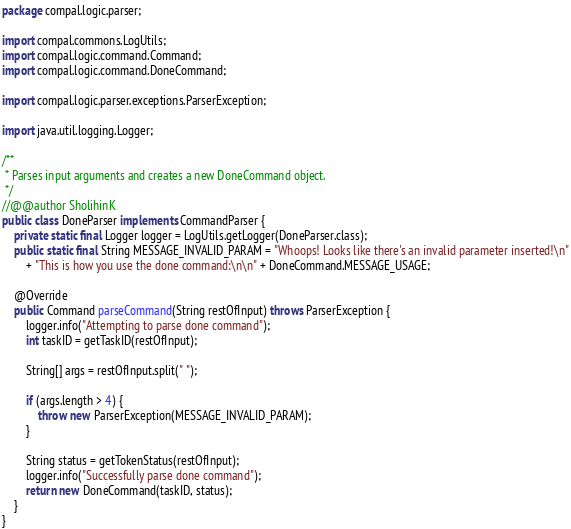<code> <loc_0><loc_0><loc_500><loc_500><_Java_>package compal.logic.parser;

import compal.commons.LogUtils;
import compal.logic.command.Command;
import compal.logic.command.DoneCommand;

import compal.logic.parser.exceptions.ParserException;

import java.util.logging.Logger;

/**
 * Parses input arguments and creates a new DoneCommand object.
 */
//@@author SholihinK
public class DoneParser implements CommandParser {
    private static final Logger logger = LogUtils.getLogger(DoneParser.class);
    public static final String MESSAGE_INVALID_PARAM = "Whoops! Looks like there's an invalid parameter inserted!\n"
        + "This is how you use the done command:\n\n" + DoneCommand.MESSAGE_USAGE;

    @Override
    public Command parseCommand(String restOfInput) throws ParserException {
        logger.info("Attempting to parse done command");
        int taskID = getTaskID(restOfInput);

        String[] args = restOfInput.split(" ");

        if (args.length > 4) {
            throw new ParserException(MESSAGE_INVALID_PARAM);
        }

        String status = getTokenStatus(restOfInput);
        logger.info("Successfully parse done command");
        return new DoneCommand(taskID, status);
    }
}
</code> 